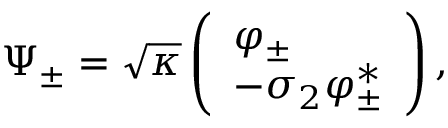Convert formula to latex. <formula><loc_0><loc_0><loc_500><loc_500>\Psi _ { \pm } = \sqrt { \kappa } \left ( \begin{array} { l } { { \varphi _ { \pm } } } \\ { { - \sigma _ { 2 } \varphi _ { \pm } ^ { \ast } } } \end{array} \right ) ,</formula> 